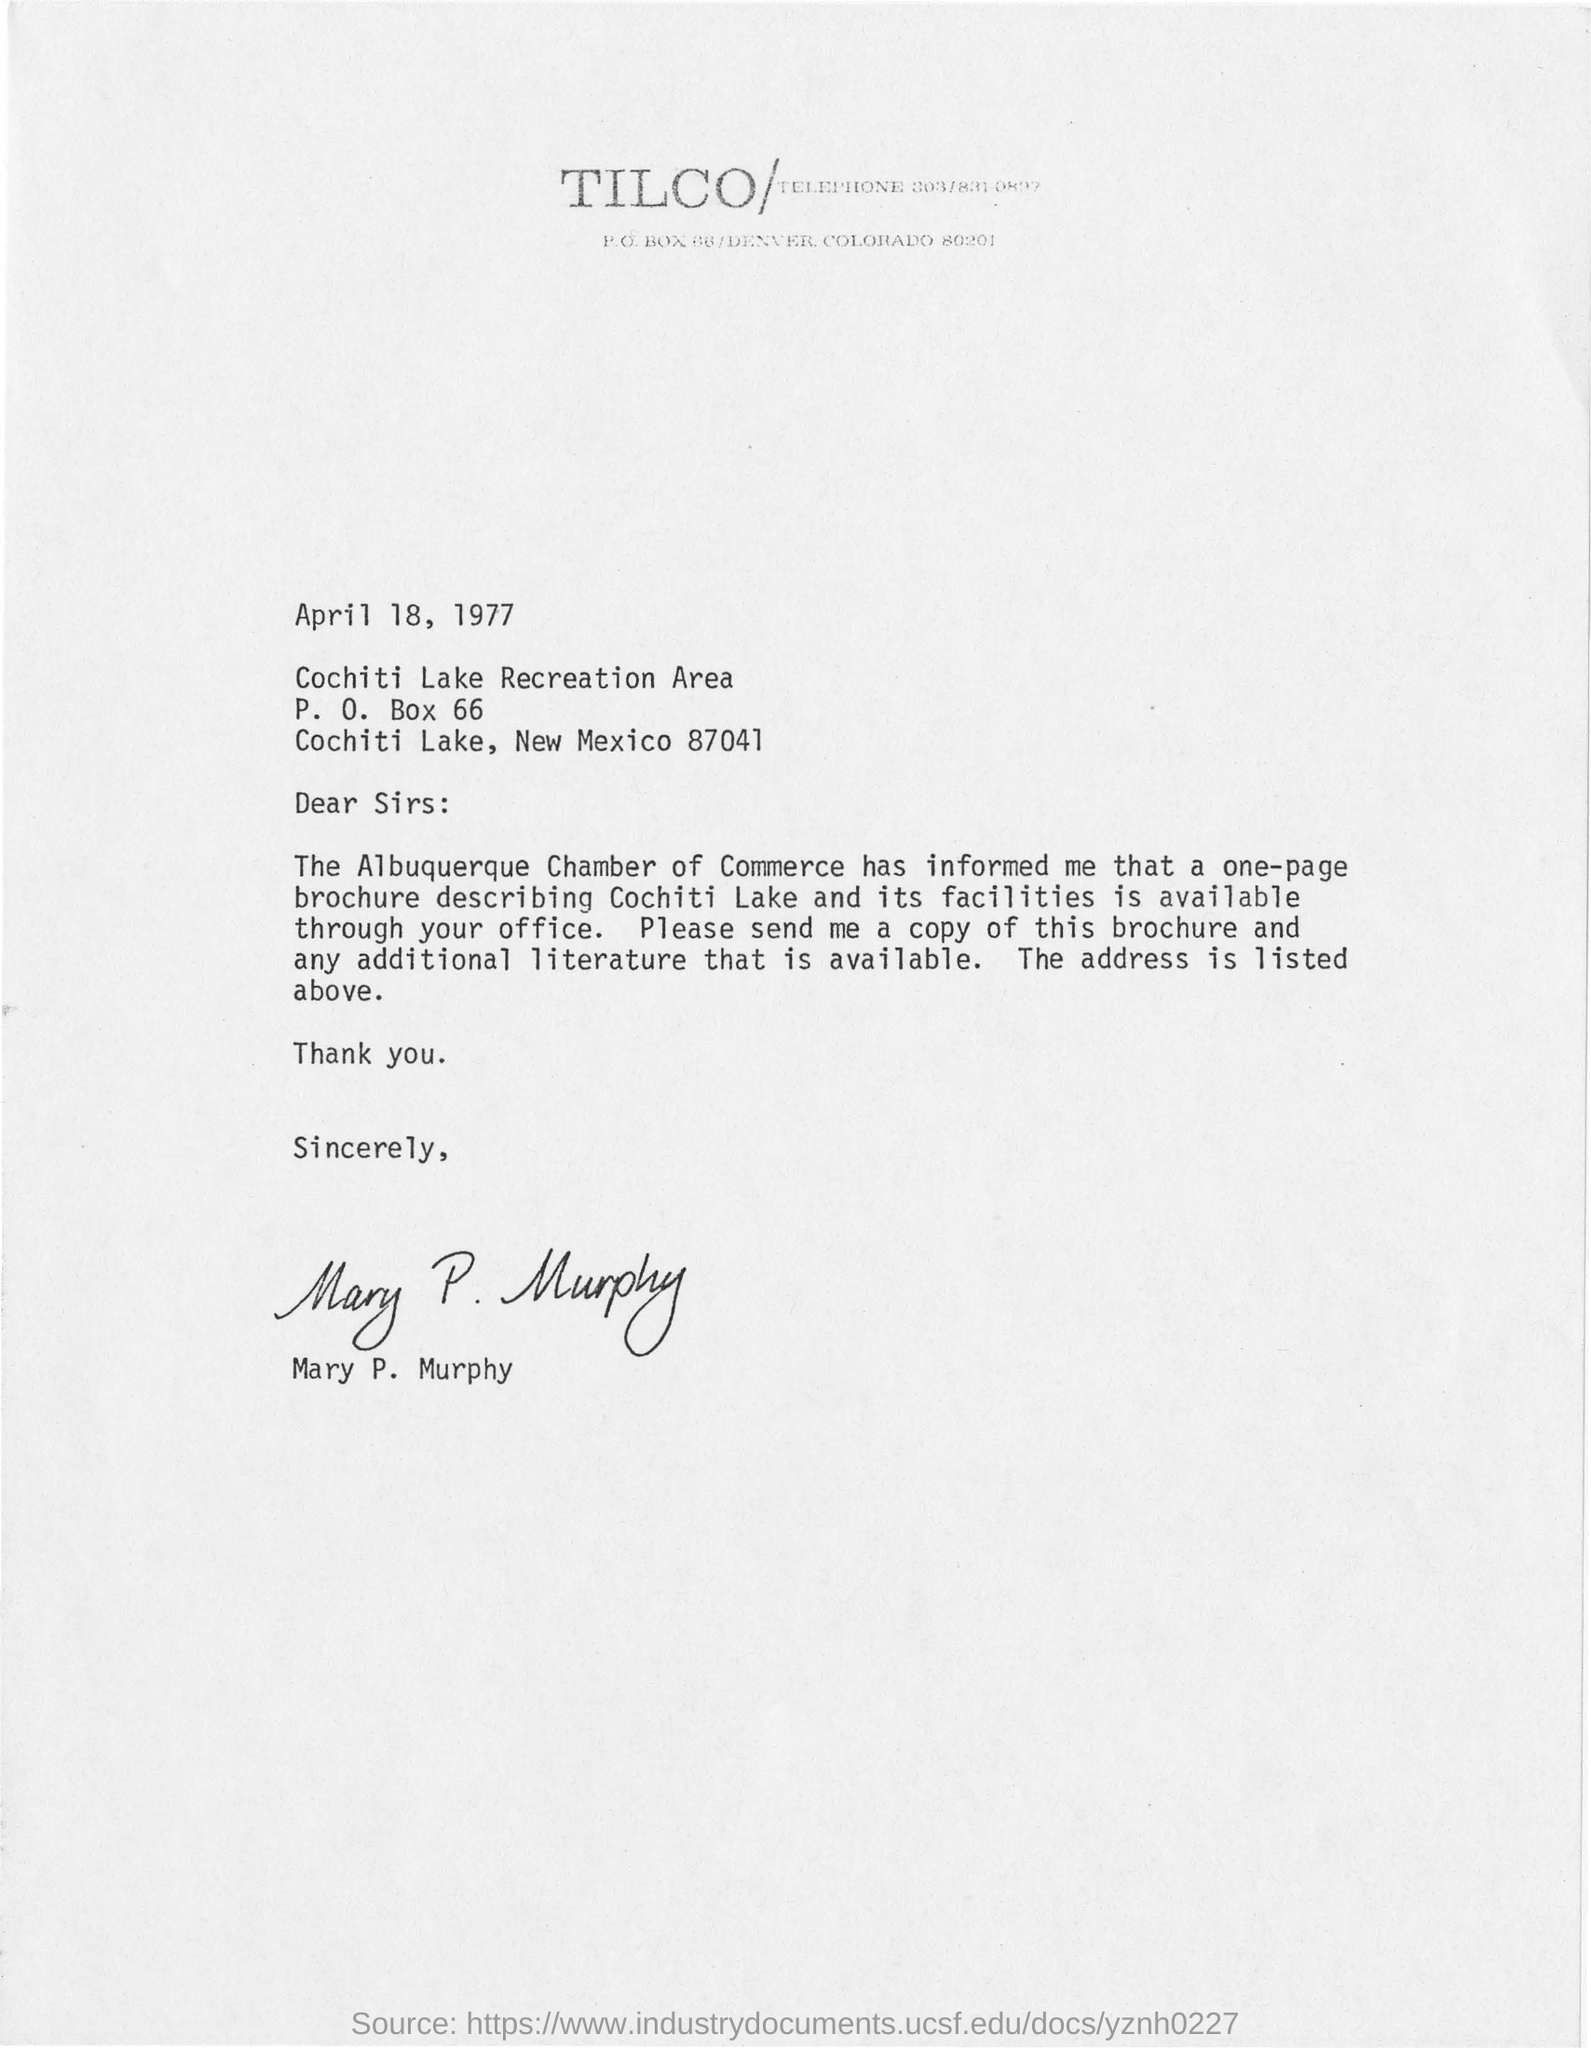What is the date of the letter?
Provide a succinct answer. April 18, 1977. What is the P.O Box Number in the letter?
Make the answer very short. 66. Who wrote this letter?
Ensure brevity in your answer.  MARY P. MURPHY. 